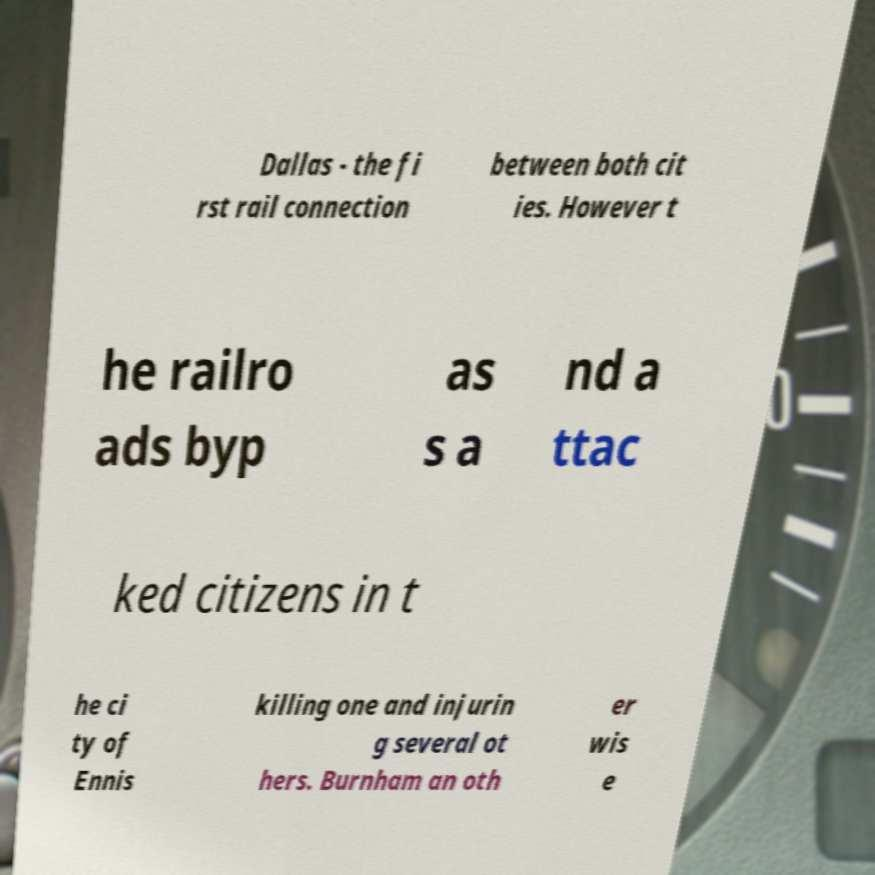Please identify and transcribe the text found in this image. Dallas - the fi rst rail connection between both cit ies. However t he railro ads byp as s a nd a ttac ked citizens in t he ci ty of Ennis killing one and injurin g several ot hers. Burnham an oth er wis e 